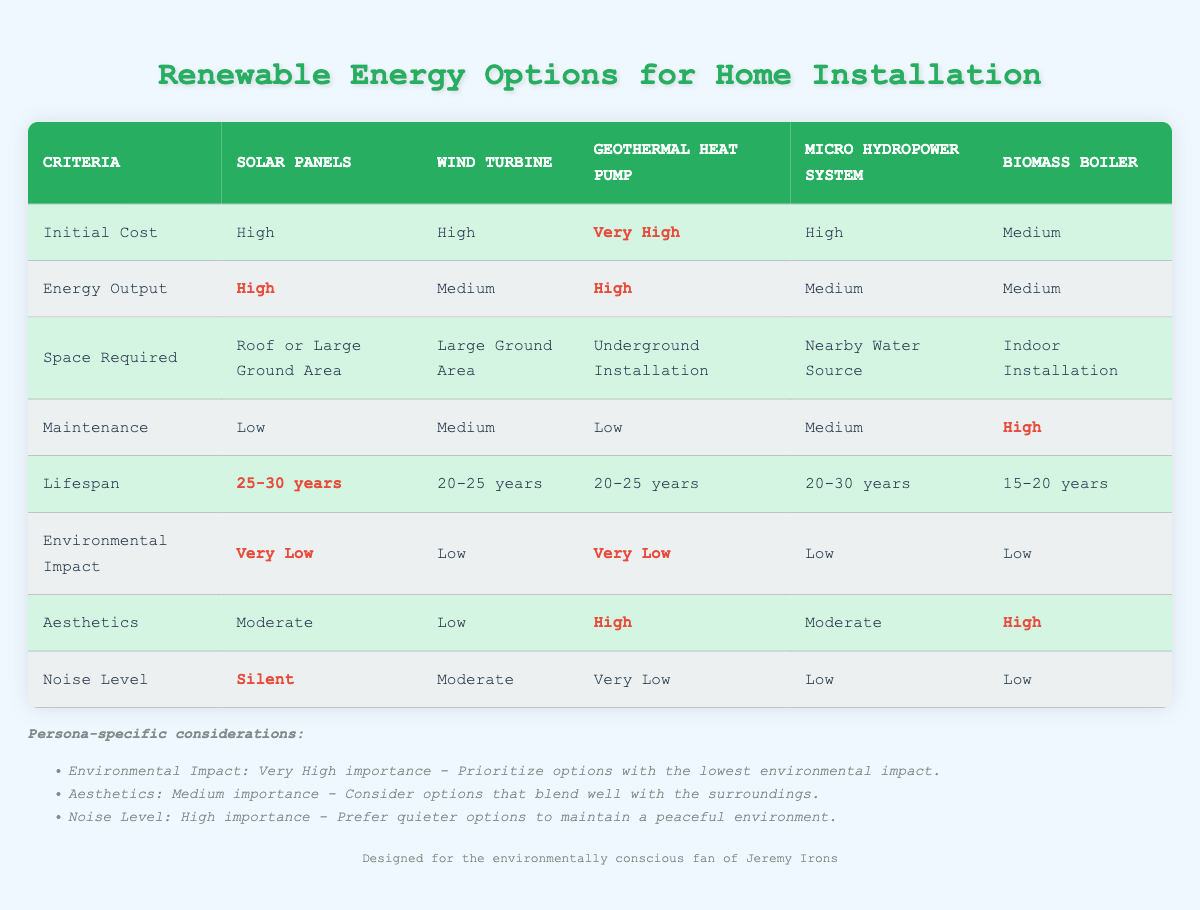What is the initial cost of the Geothermal Heat Pump? The table shows the initial cost for the Geothermal Heat Pump is stated as "Very High" in the respective column under "Initial Cost."
Answer: Very High Which renewable energy option has the highest environmental impact? From the table, the environmental impact for each option is listed, with the Solar Panels and Geothermal Heat Pump both having "Very Low." Therefore, none have the highest impact, but the Wind Turbine has "Low," making it the worst out of the options listed.
Answer: Wind Turbine How many options have a maintenance level categorized as High? To answer this, we look through the maintenance row. The only option listed as "High" is the Biomass Boiler. Thus, there is only one option with High maintenance.
Answer: 1 Which option is the best choice for someone prioritizing a silent system? Since the Noise Level for Solar Panels is "Silent," and for other options, it varies with some rated as Low or Moderate, the table clearly indicates that Solar Panels is the best choice for a silent installation.
Answer: Solar Panels What is the average lifespan of the renewable energy options listed? The lifespans provided are 25-30 years for Solar Panels, 20-25 years for Wind Turbine, 20-25 years for Geothermal Heat Pump, 20-30 years for Micro Hydropower, and 15-20 years for Biomass Boiler. The average is calculated by finding the midpoints: (27.5 + 22.5 + 22.5 + 25 + 17.5)/5 = 23.5 years.
Answer: 23.5 years Is it true that the Wind Turbine has a lower energy output than the Solar Panels? The table shows that the energy output for Solar Panels is "High" while that for Wind Turbine is "Medium." Therefore, it is indeed true that Wind Turbine has a lower output than Solar Panels.
Answer: Yes Which renewable energy option requires underground installation? The table mentions that the Geothermal Heat Pump is the only option that requires "Underground Installation" as indicated in the "Space Required" column.
Answer: Geothermal Heat Pump How does the maintenance requirement of Biomass Boiler compare to the others? In the maintenance row, the Biomass Boiler is characterized as "High." In contrast, Solar Panels and Geothermal Heat Pump have "Low," while the Wind Turbine and Micro Hydropower are "Medium." Therefore, Biomass Boiler requires more maintenance than Solar Panels and Geothermal Heat Pump but the same as Wind Turbine and Micro Hydropower.
Answer: Higher than Solar Panels and Geothermal Heat Pump, the same as Wind Turbine and Micro Hydropower 